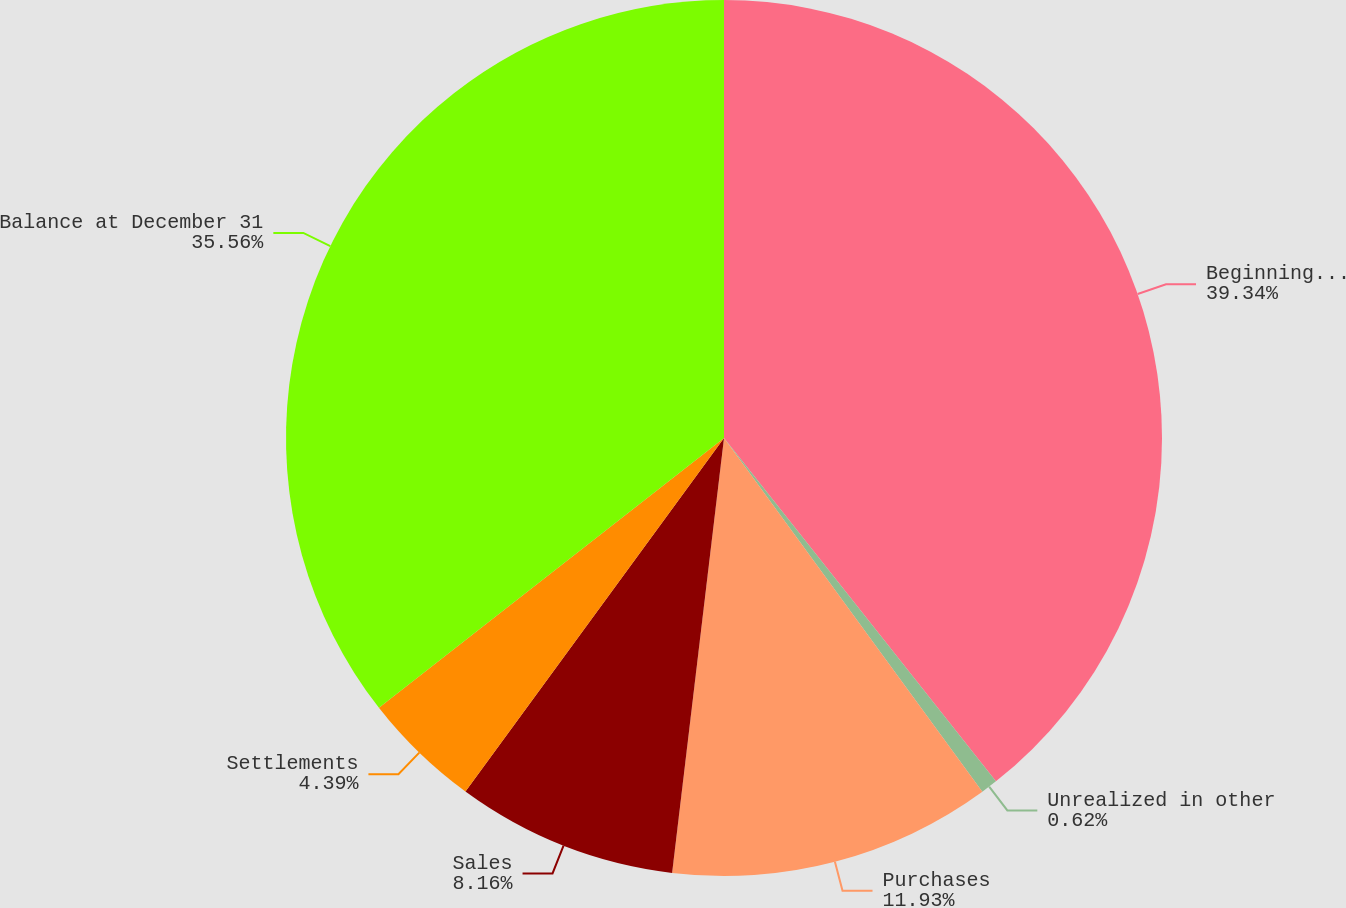<chart> <loc_0><loc_0><loc_500><loc_500><pie_chart><fcel>Beginning balance at January 1<fcel>Unrealized in other<fcel>Purchases<fcel>Sales<fcel>Settlements<fcel>Balance at December 31<nl><fcel>39.34%<fcel>0.62%<fcel>11.93%<fcel>8.16%<fcel>4.39%<fcel>35.56%<nl></chart> 